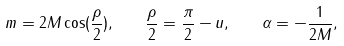<formula> <loc_0><loc_0><loc_500><loc_500>m = 2 M \cos ( \frac { \rho } { 2 } ) , \quad \frac { \rho } { 2 } = \frac { \pi } { 2 } - u , \quad \alpha = - \frac { 1 } { 2 M } ,</formula> 